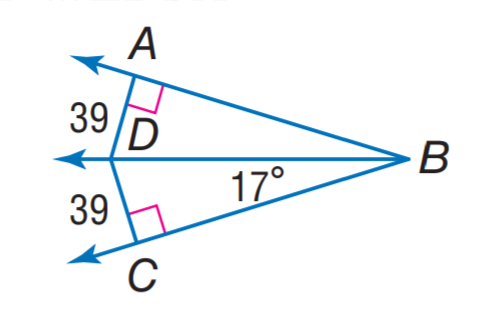If ∠CBA is 17 degrees, what would be the measure of angle ∠ABC? Given that the sum of angles in a triangle equals 180 degrees, and angles ∠CBA and ∠BAC both measure 39 degrees, we can find the measure of ∠ABC by subtracting the measures of ∠CBA and ∠BAC from 180 degrees. Therefore, ∠ABC would measure 180 - 39 - 39, which equals 102 degrees. 